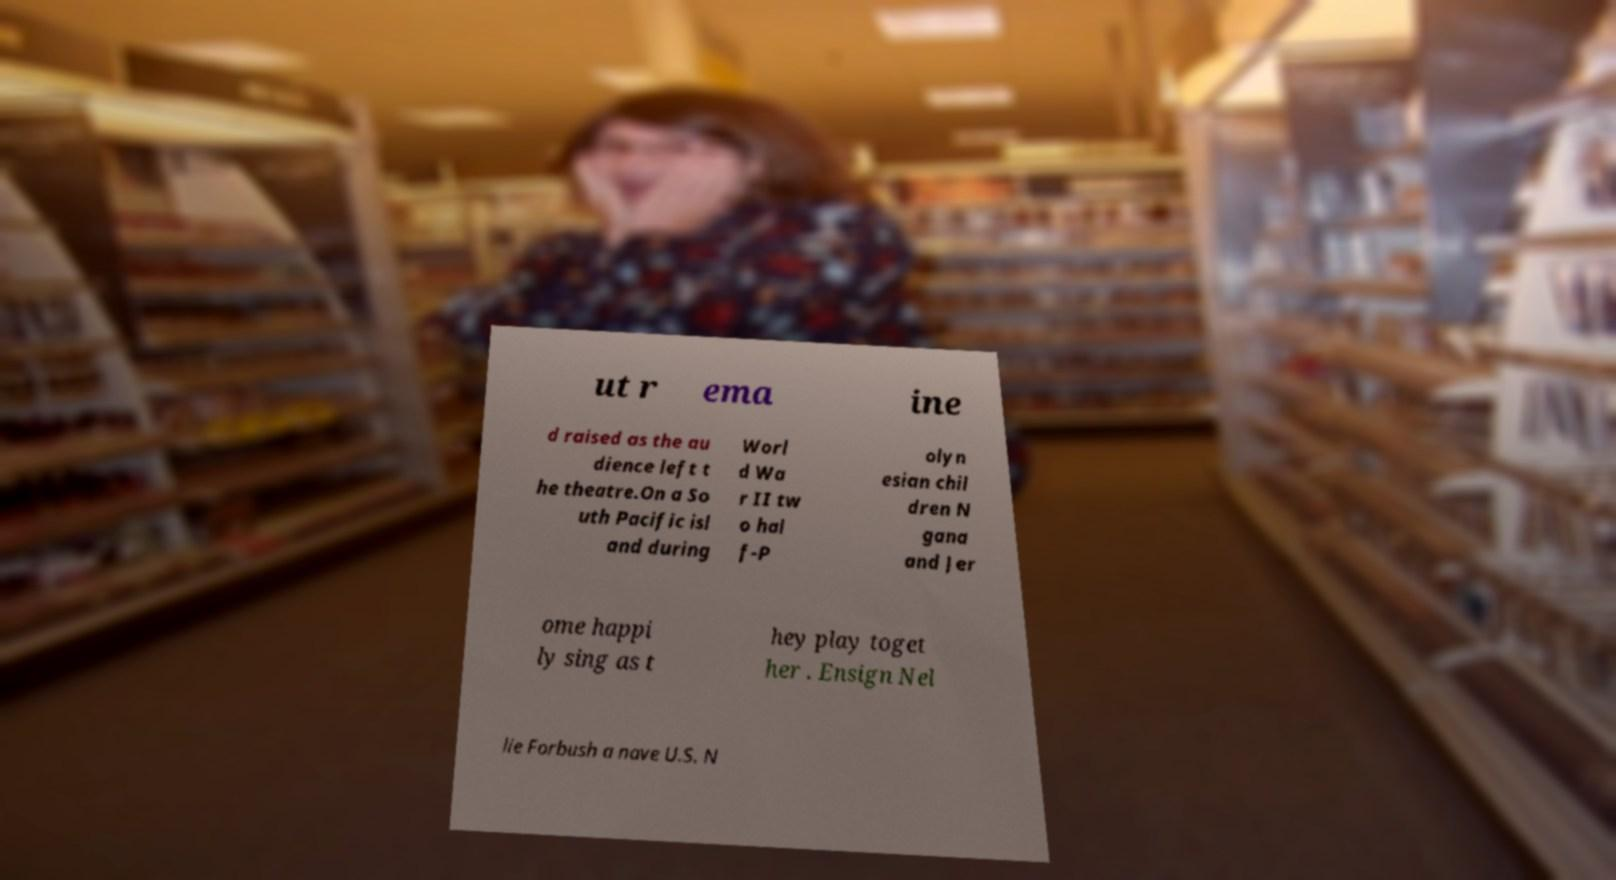There's text embedded in this image that I need extracted. Can you transcribe it verbatim? ut r ema ine d raised as the au dience left t he theatre.On a So uth Pacific isl and during Worl d Wa r II tw o hal f-P olyn esian chil dren N gana and Jer ome happi ly sing as t hey play toget her . Ensign Nel lie Forbush a nave U.S. N 